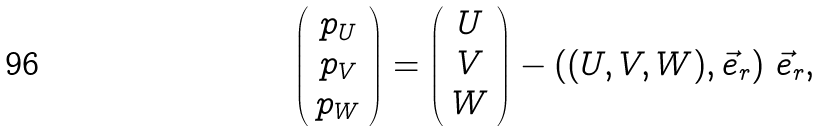Convert formula to latex. <formula><loc_0><loc_0><loc_500><loc_500>\left ( \begin{array} { c } p _ { U } \\ p _ { V } \\ p _ { W } \end{array} \right ) = \left ( \begin{array} { c } U \\ V \\ W \end{array} \right ) - \left ( ( U , V , W ) , \vec { e } _ { r } \right ) \, \vec { e } _ { r } ,</formula> 